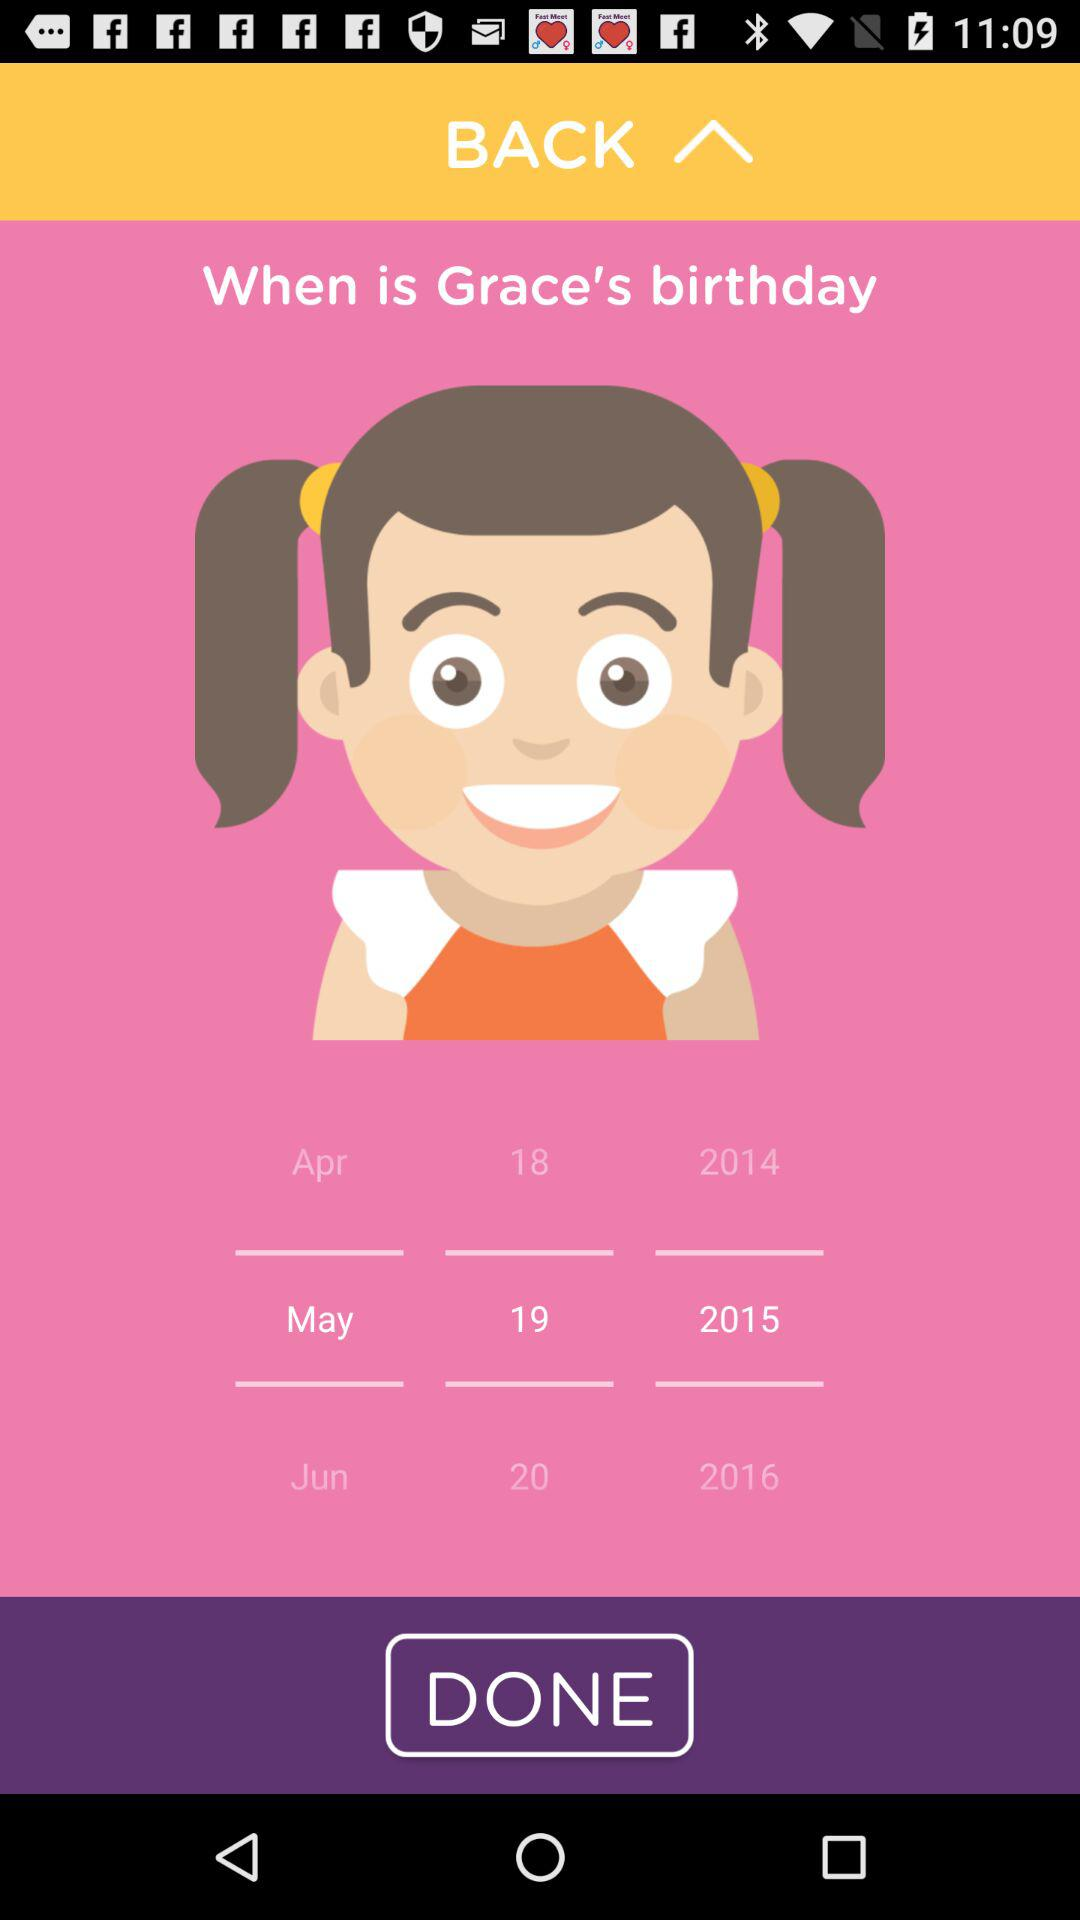What is Grace's date of birth? Grace's date of birth is May 19, 2015. 